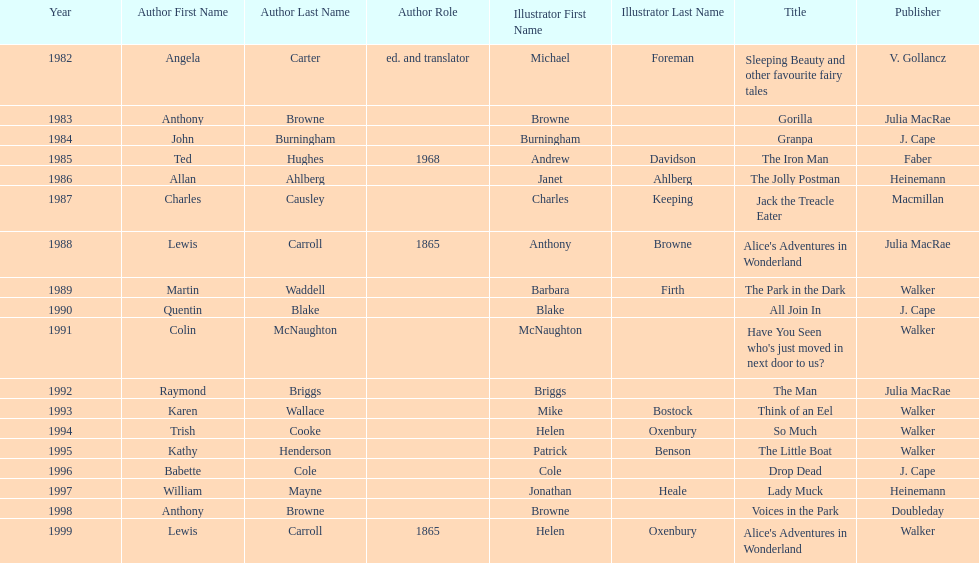How many times has anthony browne won an kurt maschler award for illustration? 3. 